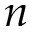<formula> <loc_0><loc_0><loc_500><loc_500>n</formula> 